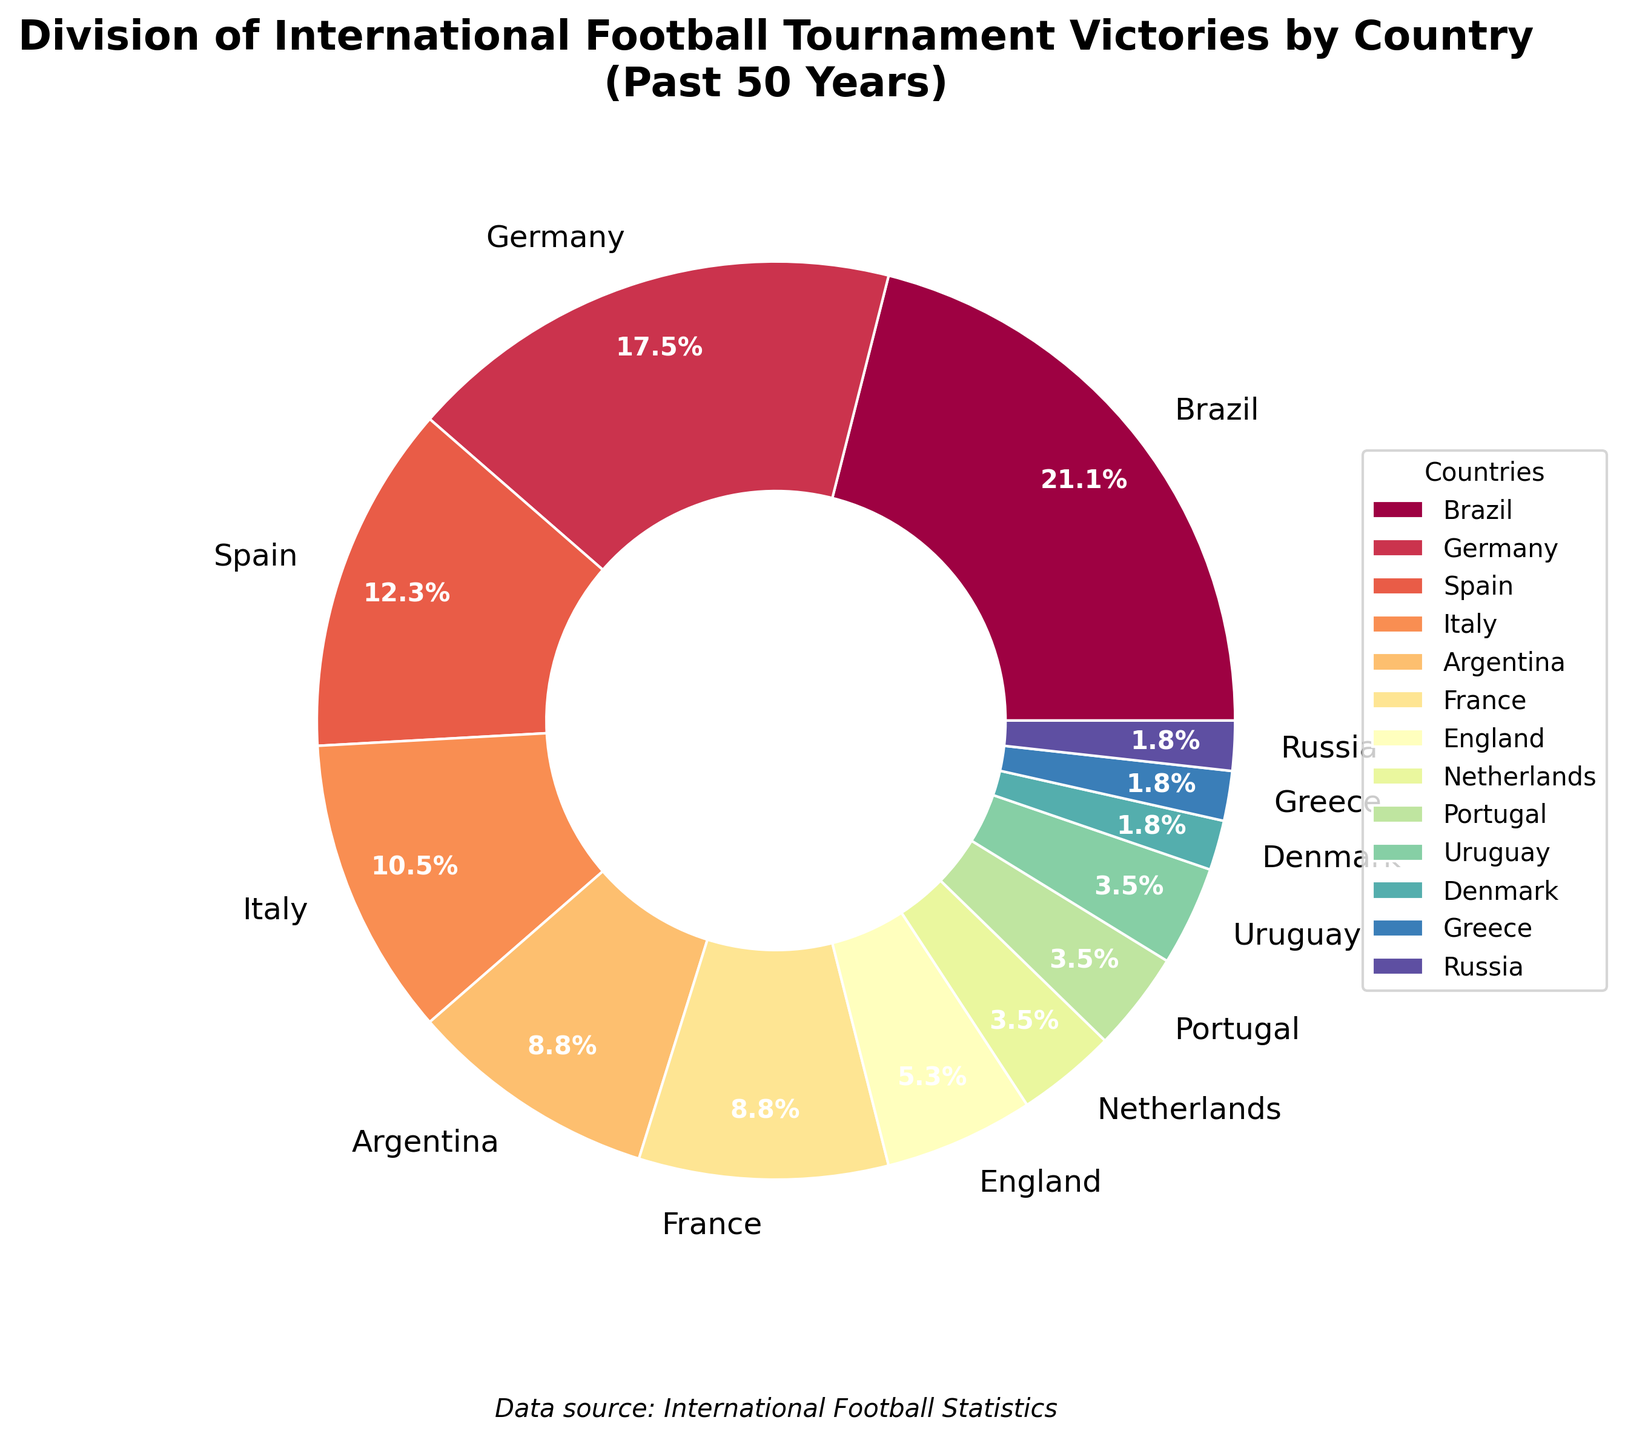Who has the most tournament victories? By looking at the pie chart, identify the country with the largest segment and highest percentage label. In this case, Brazil has 12 victories, representing the largest portion of the chart.
Answer: Brazil How many more victories does Brazil have compared to Spain? First, refer to the chart to find Brazil's victories (12) and Spain's victories (7). Then subtract Spain's victories from Brazil's victories, which is 12 - 7.
Answer: 5 Which two countries have an equal number of victories? Identify countries with the same percentage or victories listed. France and Argentina both have 5 victories each according to the chart.
Answer: France and Argentina What percentage of total victories is held by European countries? Sum the victories of European countries (Germany, Spain, Italy, France, England, Netherlands, Portugal, Denmark, Greece, Russia). Next, calculate the percentage of this total compared to the global total of victories. European countries have (10 + 7 + 6 + 5 + 3 + 2 + 2 + 1 + 1 + 1) = 38 victories. The total victories by all countries are 47. Calculate 38/47 * 100 to get the percentage.
Answer: 80.9% Which country has the smallest segment in the pie chart, and how many victories does it represent? Look at the pie chart for the smallest segment, which represents the smallest victory count. Here, Denmark, Greece, and Russia each have the smallest segments with 1 victory each.
Answer: Denmark, Greece, Russia; 1 What is the combined total victories of South American countries? Identify the South American countries from the chart (Brazil, Argentina, Uruguay). Sum their victories: Brazil (12), Argentina (5), Uruguay (2), so 12 + 5 + 2.
Answer: 19 Compare the percentage of victories of Brazil with Germany. Which one has more and by how much? Identify Brazil and Germany’s percentages from the chart: calculate the percentages as Brazil has 12 victories out of 47 (12/47 * 100) and Germany has 10 victories out of 47 (10/47 * 100). Brazil's percentage is approximately 25.5%, and Germany's is approximately 21.3%. The difference is 25.5% - 21.3%.
Answer: Brazil by 4.2% How many countries have more than 5 tournament victories? Identify from the chart the countries with more than 5 victories: Brazil (12), Germany (10), Spain (7), and Italy (6). Count them.
Answer: 4 What fraction of the victories does England hold? England has 3 victories out of a total of 47 victories. Convert this into a fraction. Simplified, it is 3/47.
Answer: 3/47 Which continent is represented by the most countries in the pie chart? Identify the continents each country belongs to and count the number of countries from each continent. Europe has (Germany, Spain, Italy, France, England, Netherlands, Portugal, Denmark, Greece, Russia) which is 10 countries. Count other continents to ensure Europe has the most.
Answer: Europe 